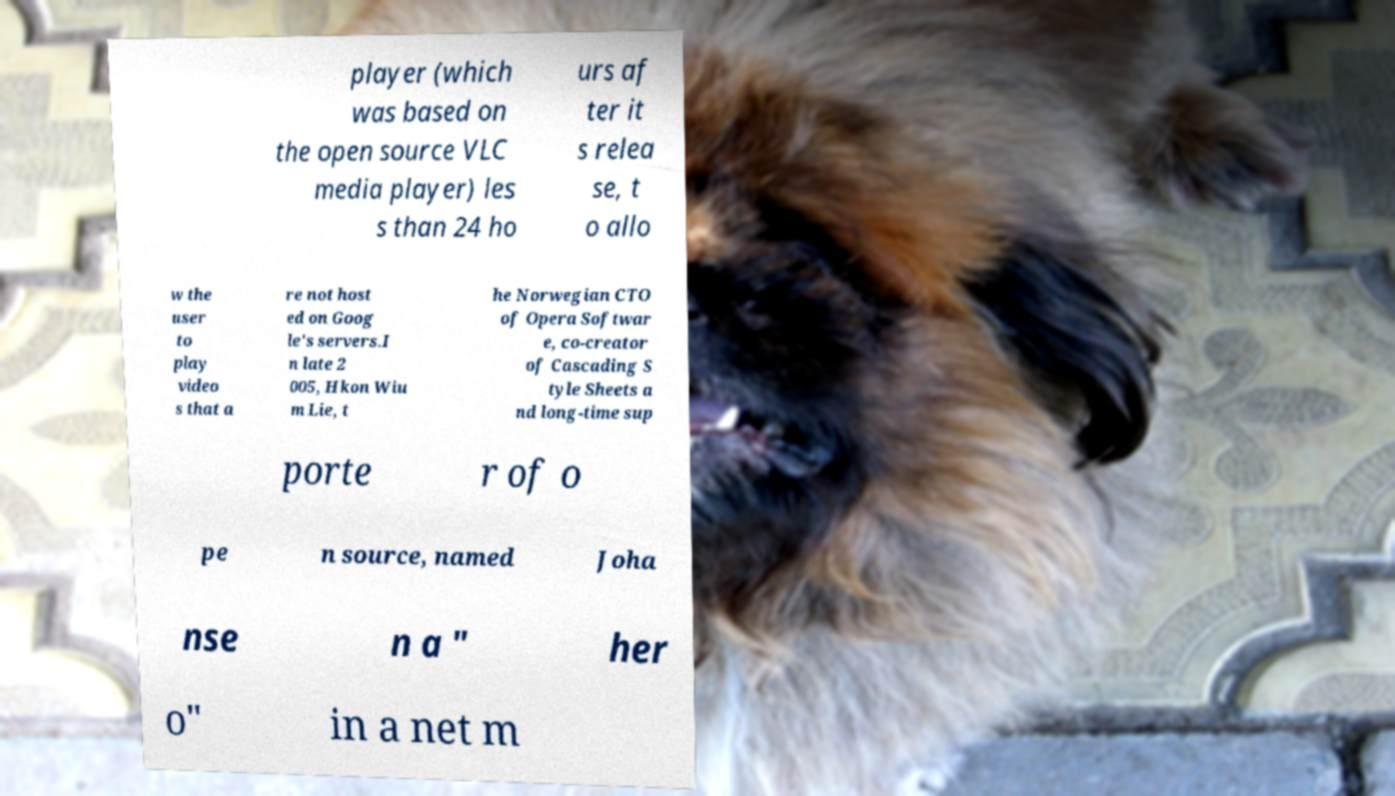Please read and relay the text visible in this image. What does it say? player (which was based on the open source VLC media player) les s than 24 ho urs af ter it s relea se, t o allo w the user to play video s that a re not host ed on Goog le's servers.I n late 2 005, Hkon Wiu m Lie, t he Norwegian CTO of Opera Softwar e, co-creator of Cascading S tyle Sheets a nd long-time sup porte r of o pe n source, named Joha nse n a " her o" in a net m 